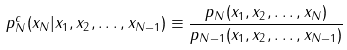Convert formula to latex. <formula><loc_0><loc_0><loc_500><loc_500>p ^ { c } _ { N } ( x _ { N } | x _ { 1 } , x _ { 2 } , \dots , x _ { N - 1 } ) \equiv \frac { p _ { N } ( x _ { 1 } , x _ { 2 } , \dots , x _ { N } ) } { p _ { N - 1 } ( x _ { 1 } , x _ { 2 } , \dots , x _ { N - 1 } ) }</formula> 